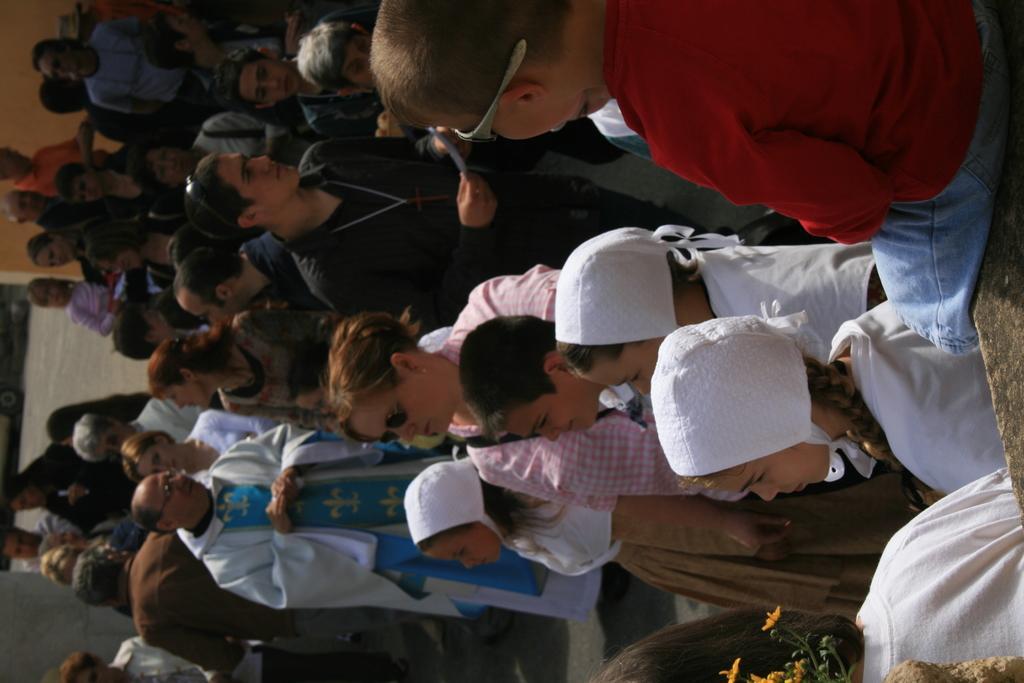How would you summarize this image in a sentence or two? In this picture, we see many people are standing. In the right top of the picture, we see a boy in red T-shirt is sitting on the wall. In front of him, we see three girls in the uniform are wearing a headscarf. On the left side, we see a wall in yellow color and a sheet in white color. 